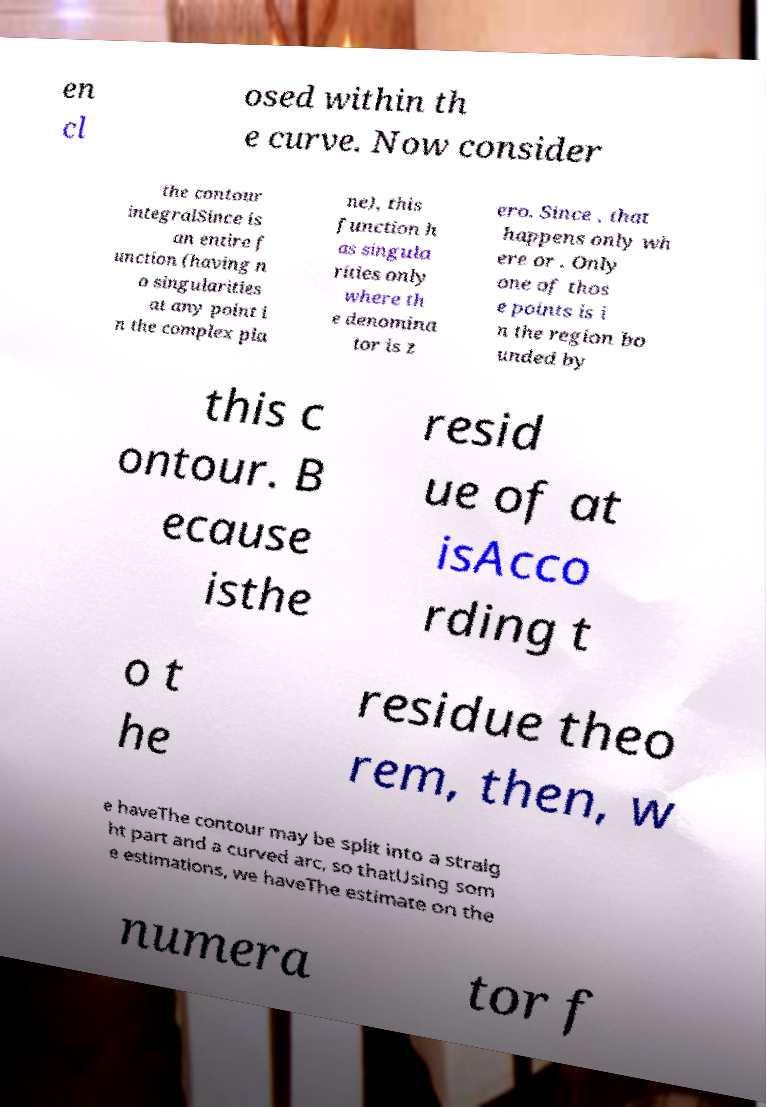Please identify and transcribe the text found in this image. en cl osed within th e curve. Now consider the contour integralSince is an entire f unction (having n o singularities at any point i n the complex pla ne), this function h as singula rities only where th e denomina tor is z ero. Since , that happens only wh ere or . Only one of thos e points is i n the region bo unded by this c ontour. B ecause isthe resid ue of at isAcco rding t o t he residue theo rem, then, w e haveThe contour may be split into a straig ht part and a curved arc, so thatUsing som e estimations, we haveThe estimate on the numera tor f 